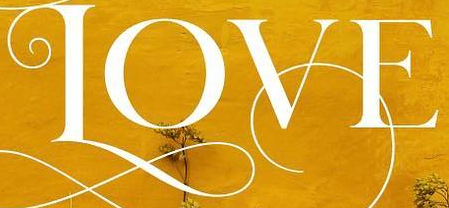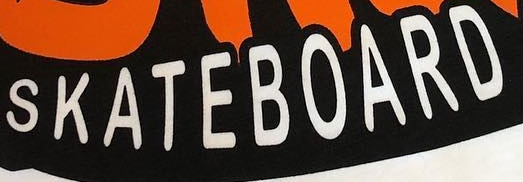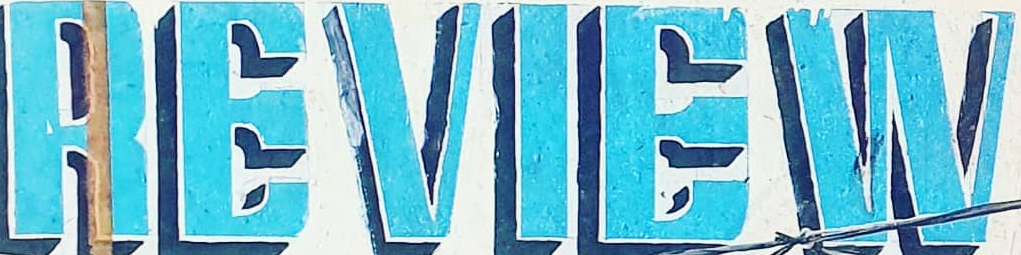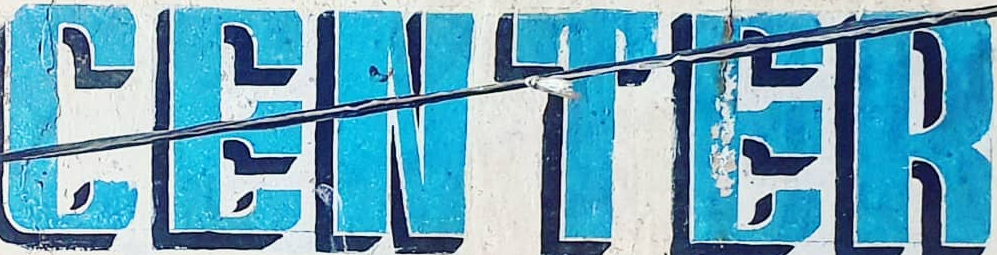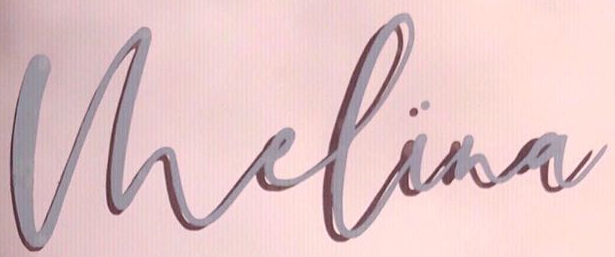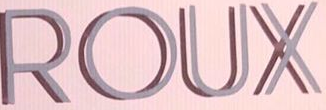What words are shown in these images in order, separated by a semicolon? LOVE; SKATEBOARD; REVIEW; CENTER; Vhelina; ROUX 